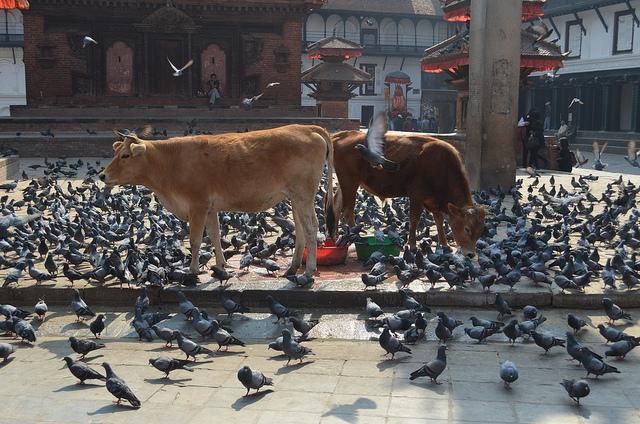How many cows can be seen?
Give a very brief answer. 2. How many books are in the image?
Give a very brief answer. 0. 